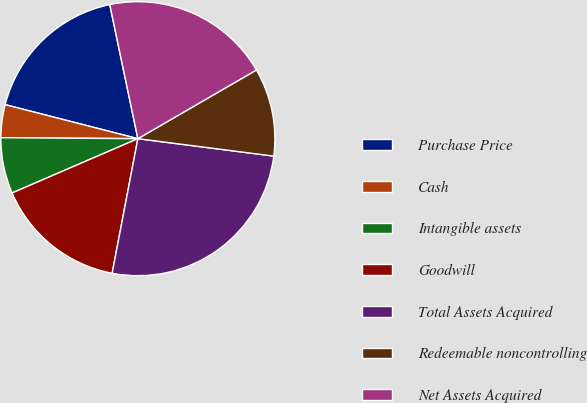Convert chart. <chart><loc_0><loc_0><loc_500><loc_500><pie_chart><fcel>Purchase Price<fcel>Cash<fcel>Intangible assets<fcel>Goodwill<fcel>Total Assets Acquired<fcel>Redeemable noncontrolling<fcel>Net Assets Acquired<nl><fcel>17.72%<fcel>3.88%<fcel>6.6%<fcel>15.51%<fcel>25.98%<fcel>10.39%<fcel>19.93%<nl></chart> 